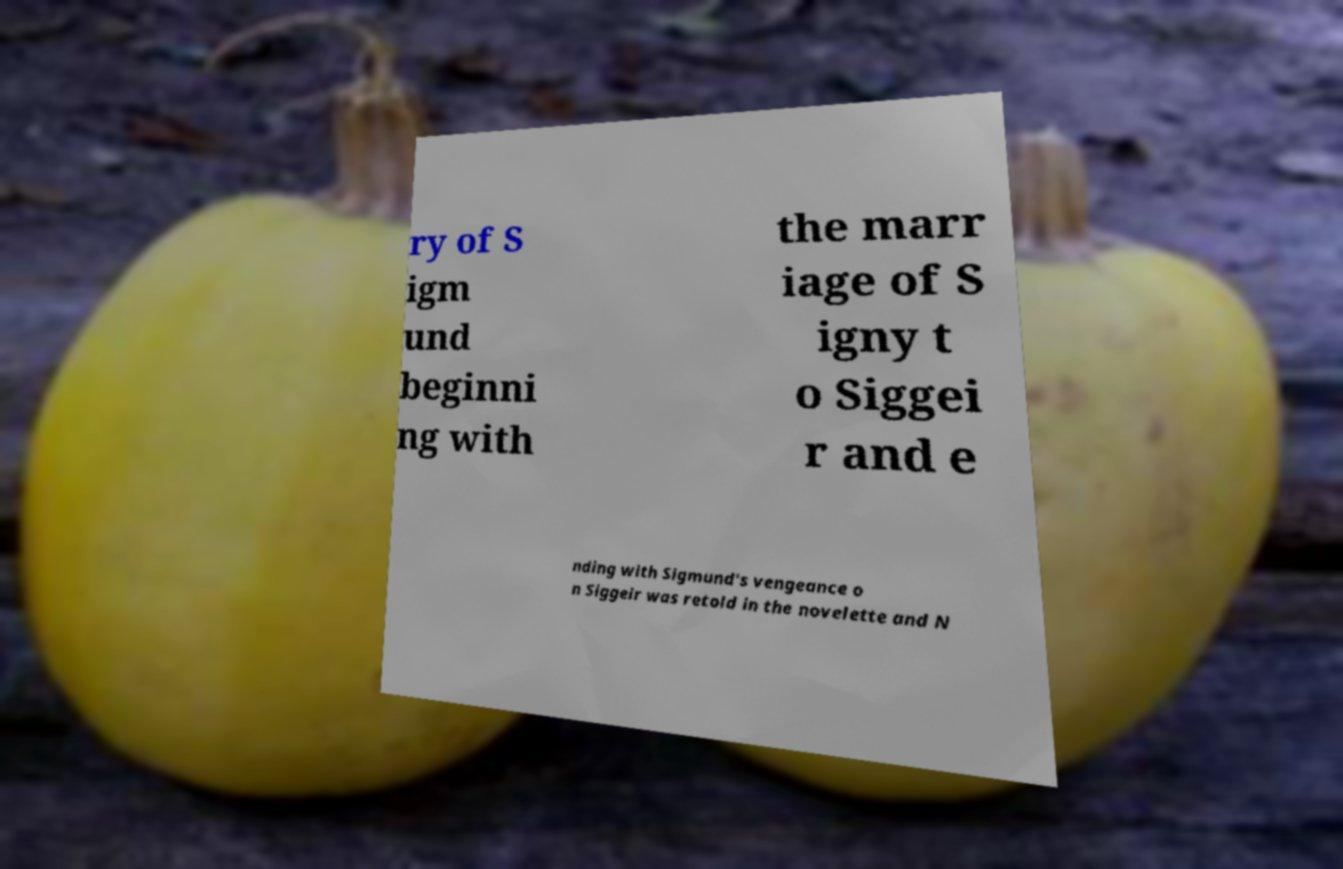Can you read and provide the text displayed in the image?This photo seems to have some interesting text. Can you extract and type it out for me? ry of S igm und beginni ng with the marr iage of S igny t o Siggei r and e nding with Sigmund's vengeance o n Siggeir was retold in the novelette and N 